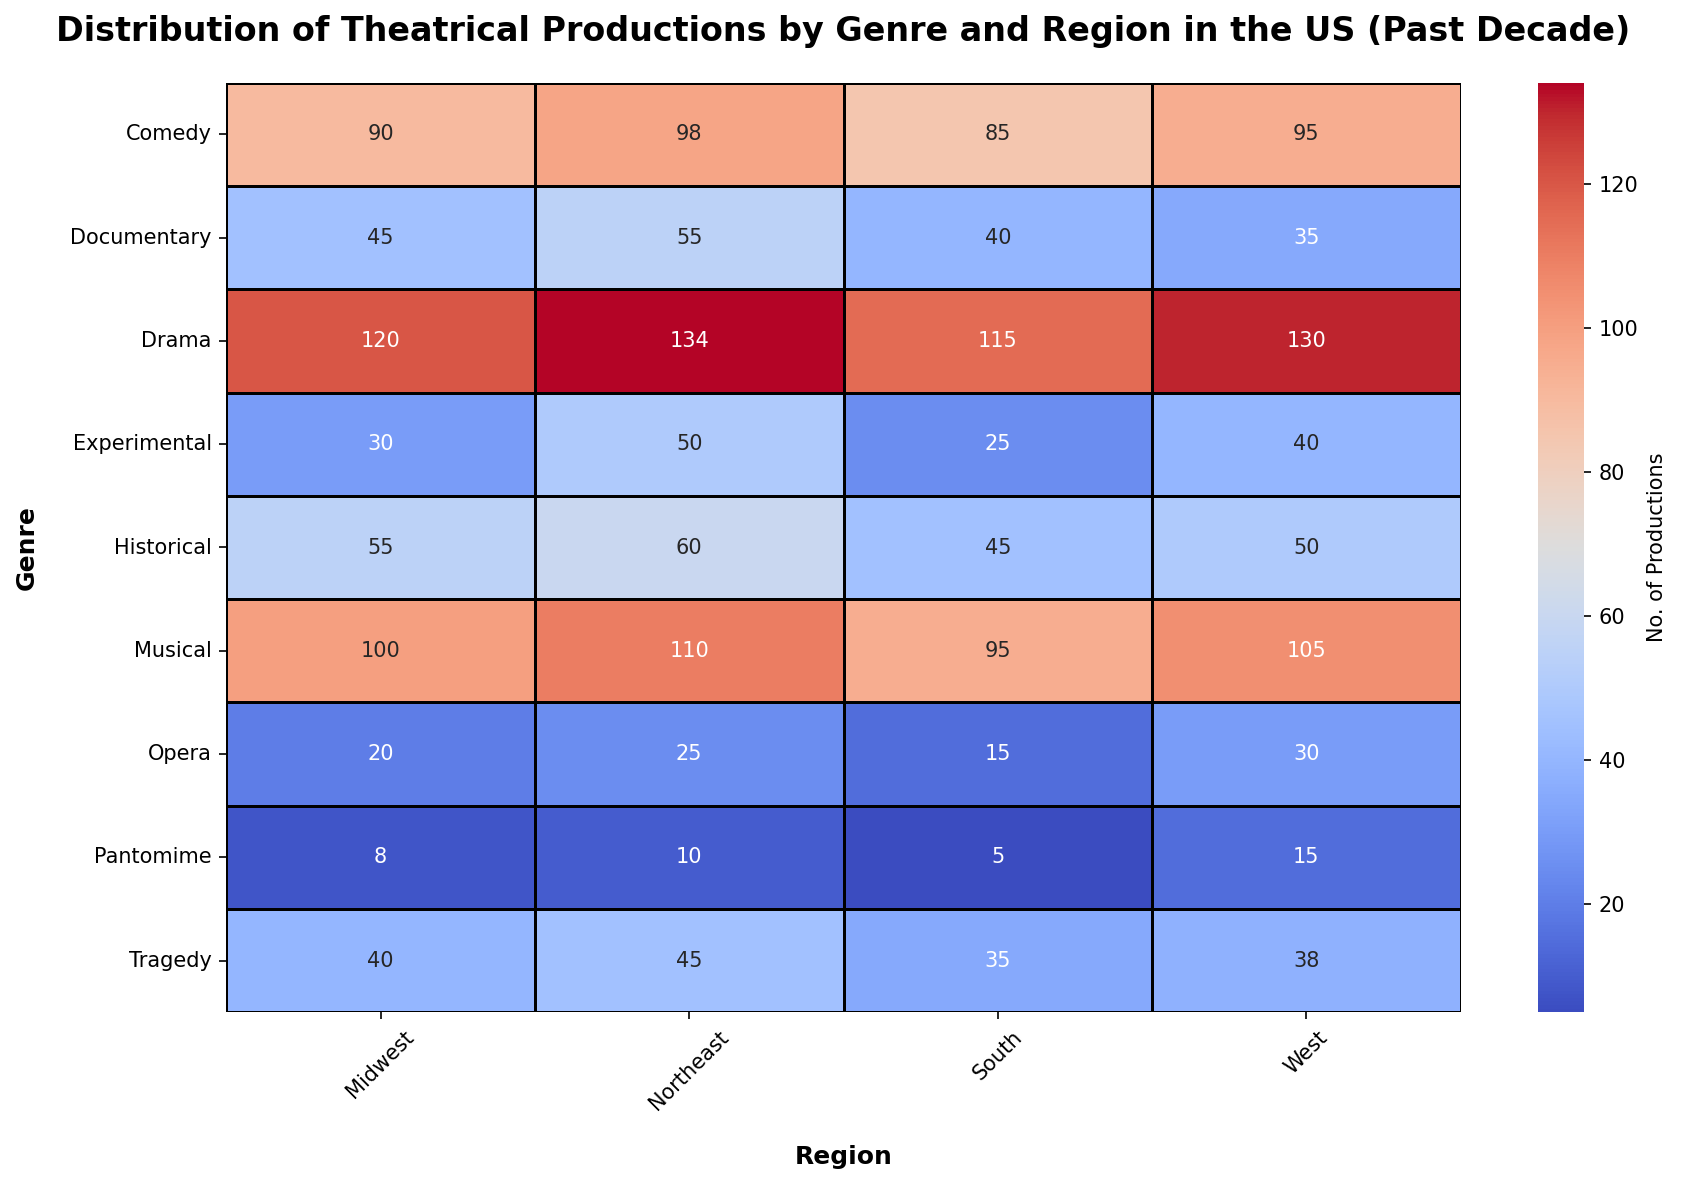What is the total number of theatrical productions in the Northeast region? To find the total number of theatrical productions in the Northeast region, sum the values for all genres: 134 (Drama) + 98 (Comedy) + 110 (Musical) + 45 (Tragedy) + 50 (Experimental) + 60 (Historical) + 55 (Documentary) + 10 (Pantomime) + 25 (Opera) = 587
Answer: 587 Which region has the highest number of Comedy productions? Compare the Comedy production numbers across all regions: Northeast (98), Midwest (90), South (85), and West (95). The Northeast has the highest number with 98
Answer: Northeast Which genre has the most productions in the Midwest region? Look at the production numbers for each genre in the Midwest region: Drama (120), Comedy (90), Musical (100), Tragedy (40), Experimental (30), Historical (55), Documentary (45), Pantomime (8), Opera (20). Drama has the highest value with 120
Answer: Drama Are there more Drama or Musical productions in the South region? Compare the numbers for Drama (115) and Musical (95) productions in the South region. The South has more Drama productions
Answer: Drama What is the difference in the number of Experimental productions between the Northeast and South regions? Subtract the number of Experimental productions in the South (25) from the number in the Northeast (50): 50 - 25 = 25
Answer: 25 Which genre has the lowest number of productions in the West region? Identify the genre with the lowest production numbers in the West region: Drama (130), Comedy (95), Musical (105), Tragedy (38), Experimental (40), Historical (50), Documentary (35), Pantomime (15), Opera (30). Pantomime has the lowest value with 15
Answer: Pantomime How does the number of Opera productions in the West compare to those in the Midwest? Compare the number of Opera productions between the West (30) and Midwest (20). The West has more Opera productions
Answer: West What is the sum of productions for the Historical genre across all regions? Sum the Historical production numbers for all regions: Northeast (60) + Midwest (55) + South (45) + West (50) = 210
Answer: 210 Which region has a higher total number of Experimental and Documentary productions combined, the Midwest or the West? Sum the Experimental and Documentary productions for the Midwest (30 + 45 = 75) and the West (40 + 35 = 75). Both regions have the same number, 75
Answer: Equal Which genre shows a greater variation in the number of productions across regions, Historical or Documentary? Compare the range (max - min) for both genres across all regions: Historical (60 - 45 = 15) and Documentary (55 - 35 = 20). Documentary has a greater variation with 20
Answer: Documentary 